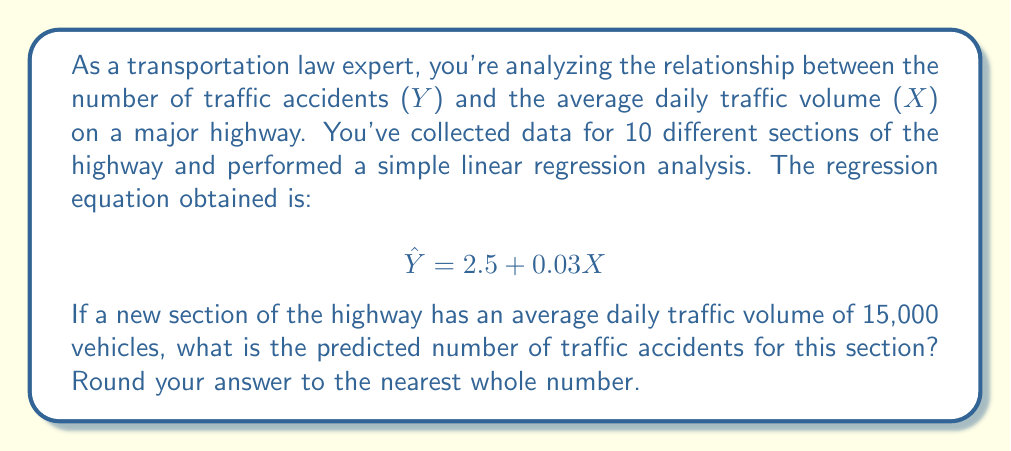Solve this math problem. To solve this problem, we'll follow these steps:

1. Understand the regression equation:
   $$ \hat{Y} = 2.5 + 0.03X $$
   Where $\hat{Y}$ is the predicted number of accidents and $X$ is the average daily traffic volume.

2. Identify the given information:
   - The new section has an average daily traffic volume of 15,000 vehicles.
   - Therefore, $X = 15,000$

3. Substitute the value of $X$ into the regression equation:
   $$ \hat{Y} = 2.5 + 0.03(15,000) $$

4. Calculate the result:
   $$ \hat{Y} = 2.5 + 450 = 452.5 $$

5. Round the result to the nearest whole number:
   452.5 rounds to 453

Therefore, the predicted number of traffic accidents for the new section with an average daily traffic volume of 15,000 vehicles is 453.
Answer: 453 